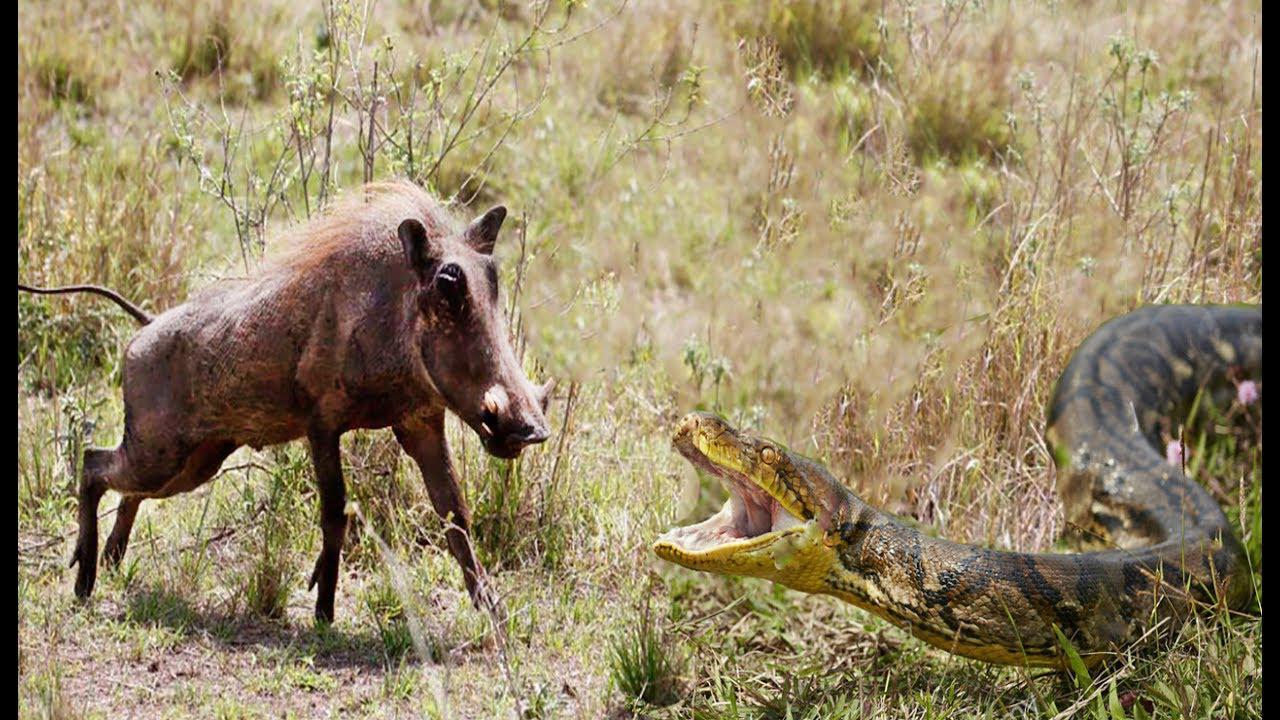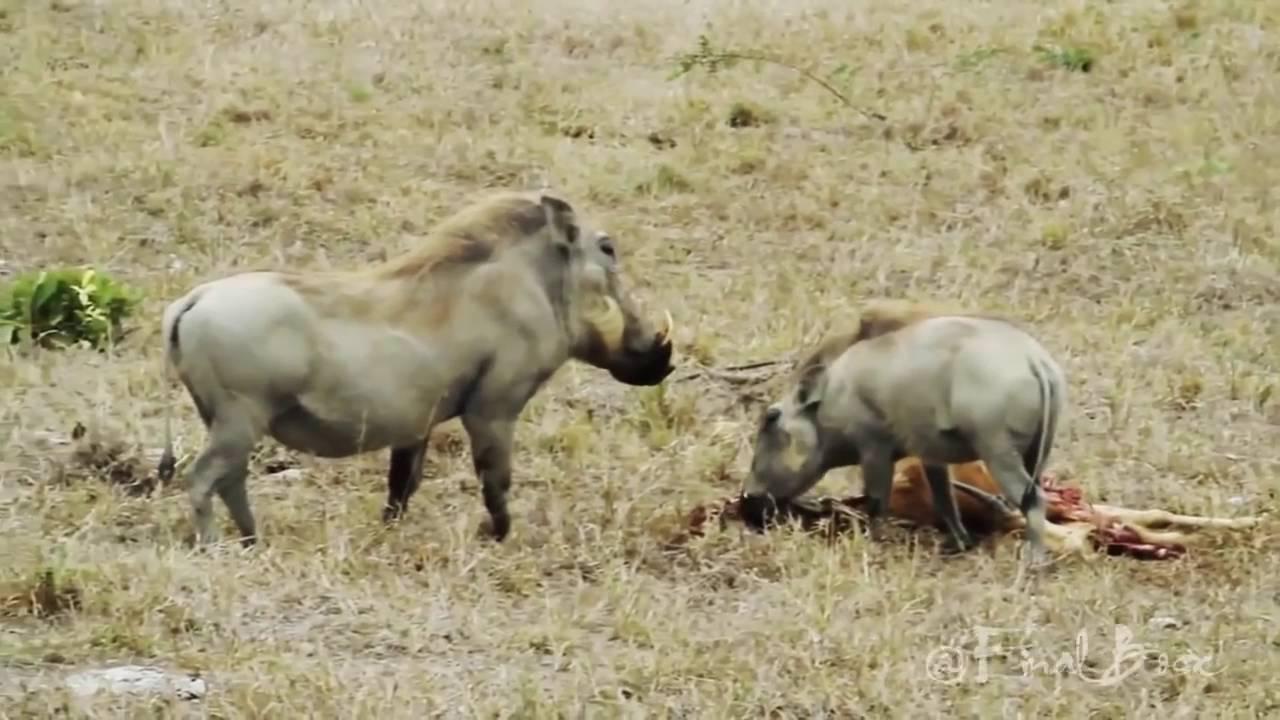The first image is the image on the left, the second image is the image on the right. Evaluate the accuracy of this statement regarding the images: "An image shows a warthog sitting upright, with multiple hogs behind it.". Is it true? Answer yes or no. No. 